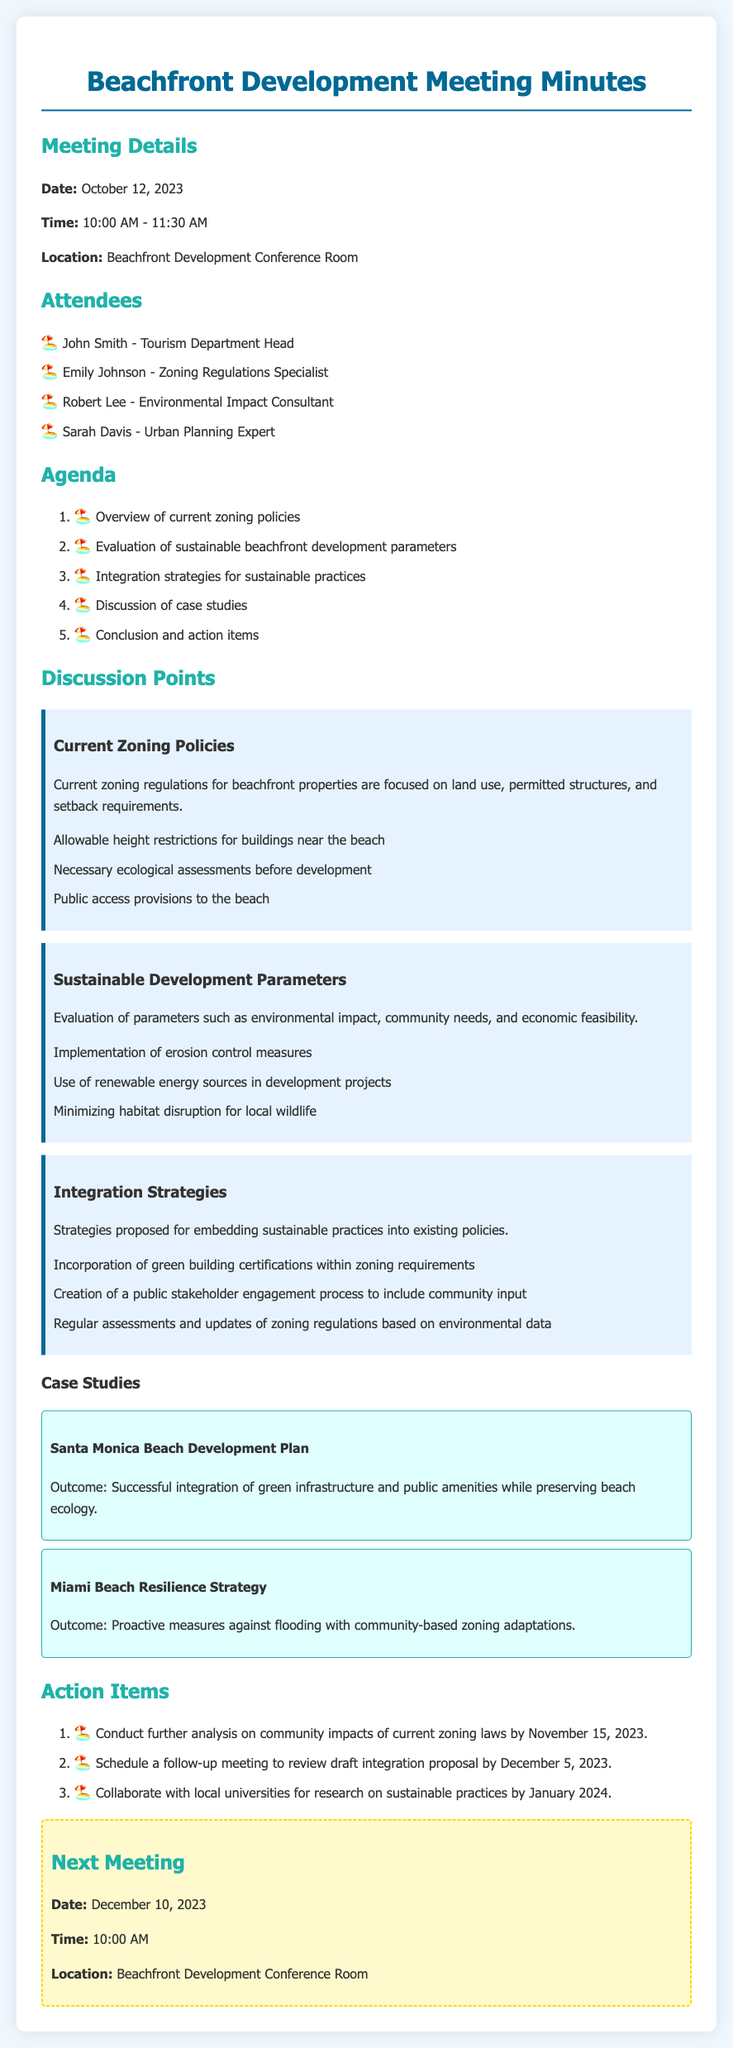what date was the meeting held? The document specifies that the meeting took place on October 12, 2023.
Answer: October 12, 2023 who is the Zoning Regulations Specialist? The document lists Emily Johnson as the Zoning Regulations Specialist among the attendees.
Answer: Emily Johnson what is one of the sustainable development parameters mentioned? The document lists the implementation of erosion control measures as a sustainable development parameter.
Answer: Erosion control measures what is a proposed integration strategy? The document states that a proposed integration strategy is the incorporation of green building certifications within zoning requirements.
Answer: Incorporation of green building certifications how many attendees were present at the meeting? The document outlines that there were four attendees present.
Answer: Four what is the outcome of the Santa Monica Beach Development Plan case study? The document indicates that the outcome was the successful integration of green infrastructure and public amenities while preserving beach ecology.
Answer: Successful integration of green infrastructure when is the next meeting scheduled? The document specifies that the next meeting is scheduled for December 10, 2023.
Answer: December 10, 2023 what is one action item related to community impacts? According to the document, the action item is to conduct further analysis on community impacts of current zoning laws by November 15, 2023.
Answer: Conduct further analysis on community impacts what location is mentioned for the follow-up meeting? The document states that the follow-up meeting will also take place in the Beachfront Development Conference Room.
Answer: Beachfront Development Conference Room 